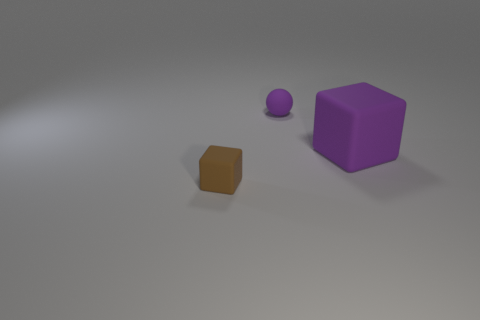Add 1 small brown rubber objects. How many objects exist? 4 Subtract 2 blocks. How many blocks are left? 0 Subtract all spheres. How many objects are left? 2 Subtract all yellow balls. Subtract all green cylinders. How many balls are left? 1 Subtract all purple blocks. How many red balls are left? 0 Subtract all small rubber blocks. Subtract all gray spheres. How many objects are left? 2 Add 3 purple balls. How many purple balls are left? 4 Add 1 small brown matte blocks. How many small brown matte blocks exist? 2 Subtract 0 blue spheres. How many objects are left? 3 